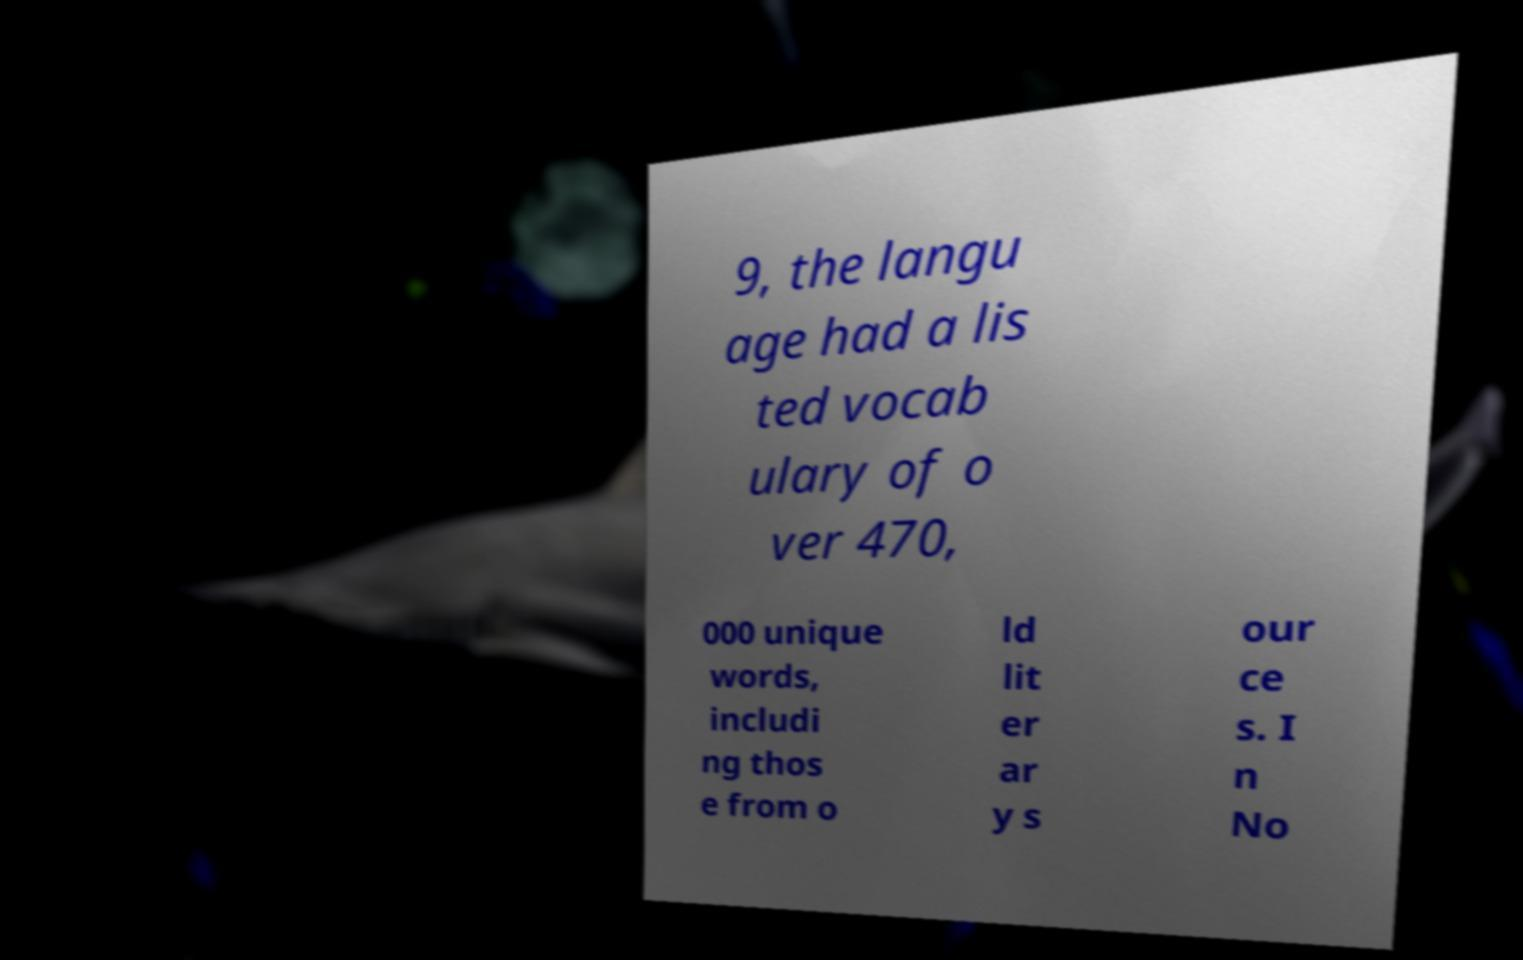Could you assist in decoding the text presented in this image and type it out clearly? 9, the langu age had a lis ted vocab ulary of o ver 470, 000 unique words, includi ng thos e from o ld lit er ar y s our ce s. I n No 